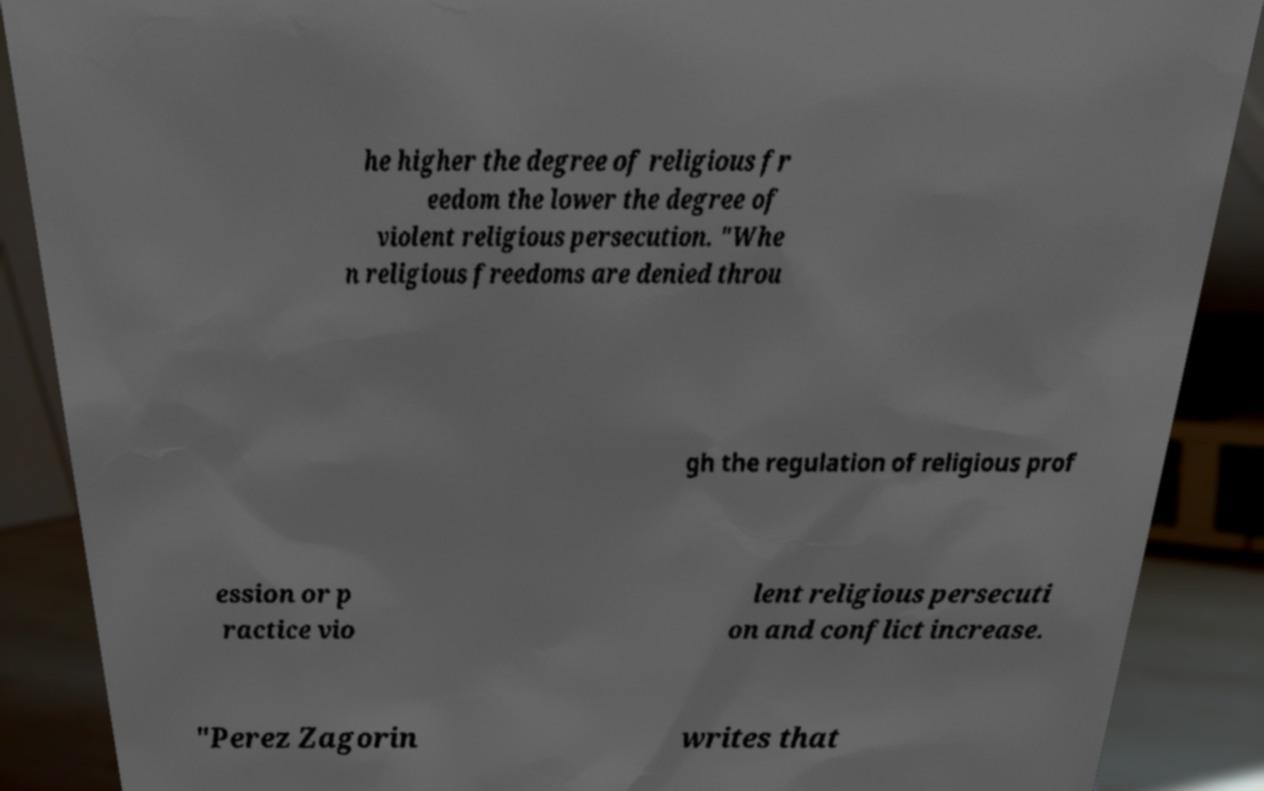Could you assist in decoding the text presented in this image and type it out clearly? he higher the degree of religious fr eedom the lower the degree of violent religious persecution. "Whe n religious freedoms are denied throu gh the regulation of religious prof ession or p ractice vio lent religious persecuti on and conflict increase. "Perez Zagorin writes that 